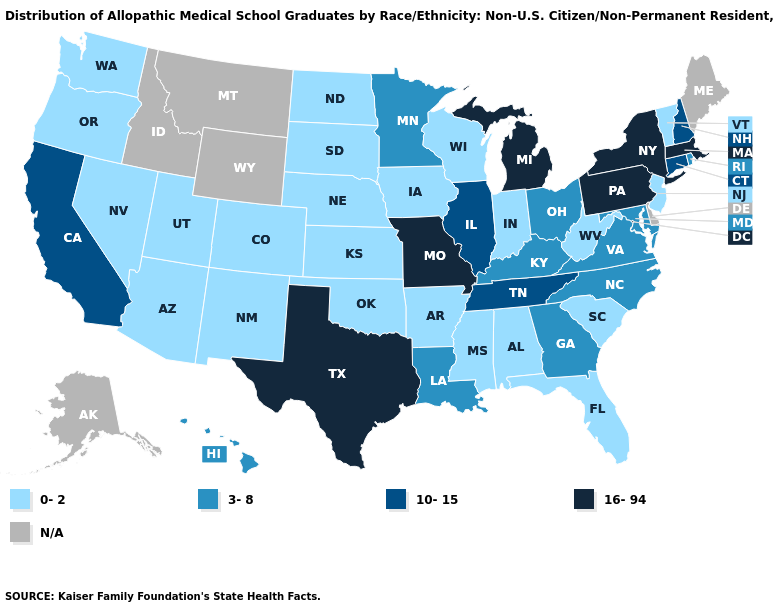Which states have the highest value in the USA?
Be succinct. Massachusetts, Michigan, Missouri, New York, Pennsylvania, Texas. What is the highest value in the USA?
Write a very short answer. 16-94. What is the value of California?
Write a very short answer. 10-15. Does Connecticut have the highest value in the Northeast?
Answer briefly. No. Does New York have the lowest value in the USA?
Keep it brief. No. Name the states that have a value in the range N/A?
Keep it brief. Alaska, Delaware, Idaho, Maine, Montana, Wyoming. Among the states that border Wisconsin , which have the lowest value?
Keep it brief. Iowa. Which states have the highest value in the USA?
Give a very brief answer. Massachusetts, Michigan, Missouri, New York, Pennsylvania, Texas. What is the value of Kansas?
Answer briefly. 0-2. Does New Hampshire have the highest value in the Northeast?
Write a very short answer. No. Name the states that have a value in the range 3-8?
Concise answer only. Georgia, Hawaii, Kentucky, Louisiana, Maryland, Minnesota, North Carolina, Ohio, Rhode Island, Virginia. Name the states that have a value in the range 16-94?
Give a very brief answer. Massachusetts, Michigan, Missouri, New York, Pennsylvania, Texas. Name the states that have a value in the range 10-15?
Write a very short answer. California, Connecticut, Illinois, New Hampshire, Tennessee. 